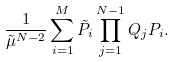Convert formula to latex. <formula><loc_0><loc_0><loc_500><loc_500>\frac { 1 } { \tilde { \mu } ^ { N - 2 } } \sum _ { i = 1 } ^ { M } \tilde { P } _ { i } \prod _ { j = 1 } ^ { N - 1 } Q _ { j } P _ { i } .</formula> 